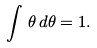Convert formula to latex. <formula><loc_0><loc_0><loc_500><loc_500>\int \, \theta \, d \theta = 1 .</formula> 